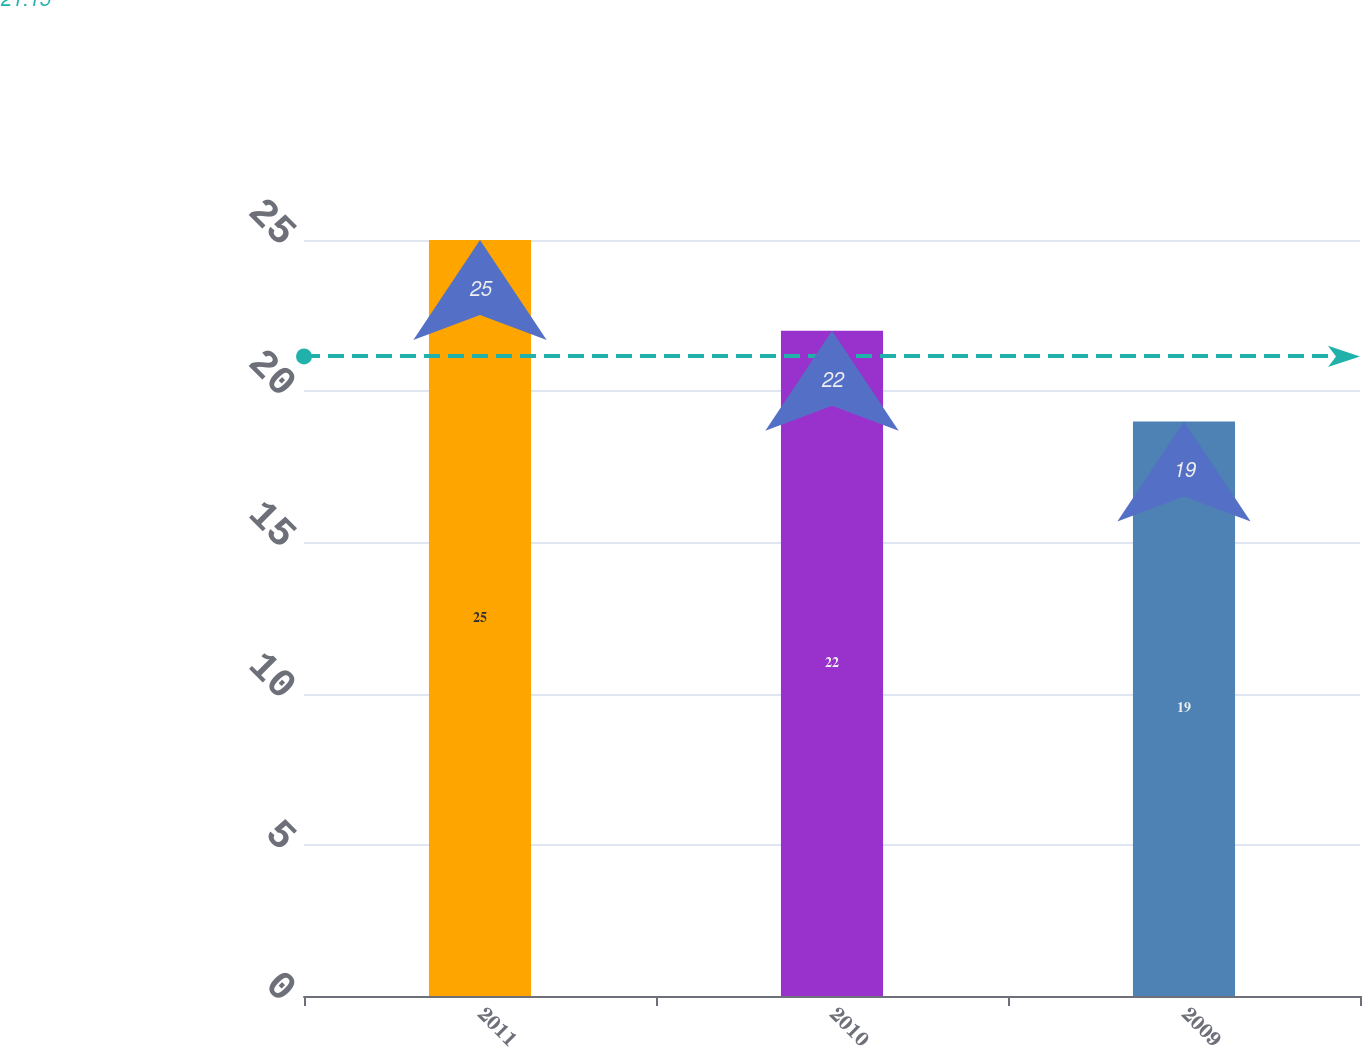Convert chart. <chart><loc_0><loc_0><loc_500><loc_500><bar_chart><fcel>2011<fcel>2010<fcel>2009<nl><fcel>25<fcel>22<fcel>19<nl></chart> 